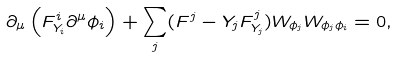<formula> <loc_0><loc_0><loc_500><loc_500>\partial _ { \mu } \left ( F ^ { i } _ { Y _ { i } } \partial ^ { \mu } \phi _ { i } \right ) + \sum _ { j } ( F ^ { j } - Y _ { j } F ^ { j } _ { Y _ { j } } ) W _ { \phi _ { j } } W _ { \phi _ { j } \phi _ { i } } = 0 ,</formula> 